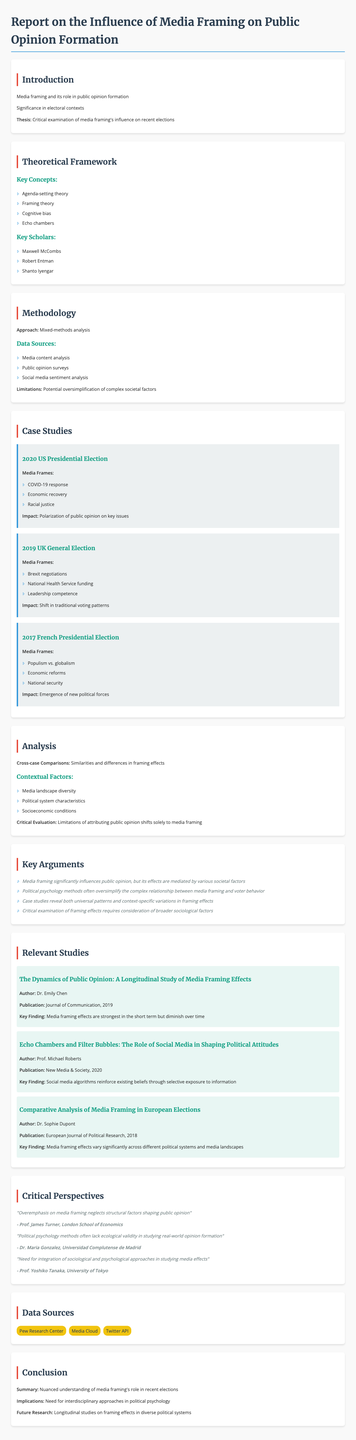what is the thesis of the report? The thesis presents the critical examination of media framing's influence on recent elections as defined in the introduction.
Answer: Critical examination of media framing's influence on recent elections who is the author of the study titled "The Dynamics of Public Opinion: A Longitudinal Study of Media Framing Effects"? This study is authored by Dr. Emily Chen, which is noted in the relevant studies section.
Answer: Dr. Emily Chen how many case studies are presented in the report? The number of case studies can be counted from the case studies section in the report.
Answer: Three what was one key media frame in the 2020 US Presidential Election? The report lists specific media frames for each case study, one being COVID-19 response.
Answer: COVID-19 response which theory is included in the theoretical framework of the report? The theoretical framework section mentions several theories, one of which is Agenda-setting theory.
Answer: Agenda-setting theory what is the key finding from the study published in 2020 by Prof. Michael Roberts? The key finding from this study is found in the relevant studies section.
Answer: Social media algorithms reinforce existing beliefs through selective exposure to information what is one limitation mentioned in the methodology of the report? The limitations are detailed in the methodology section, specifically mentioning the potential oversimplification of complex societal factors.
Answer: Potential oversimplification of complex societal factors who argued for the need for integration of sociological and psychological approaches in studying media effects? This critical perspective is attributed to Prof. Yoshiko Tanaka, as noted in the critical perspectives section.
Answer: Prof. Yoshiko Tanaka what is the summary of the conclusion? The conclusion summarises the report's findings in the conclusion section.
Answer: Nuanced understanding of media framing's role in recent elections 